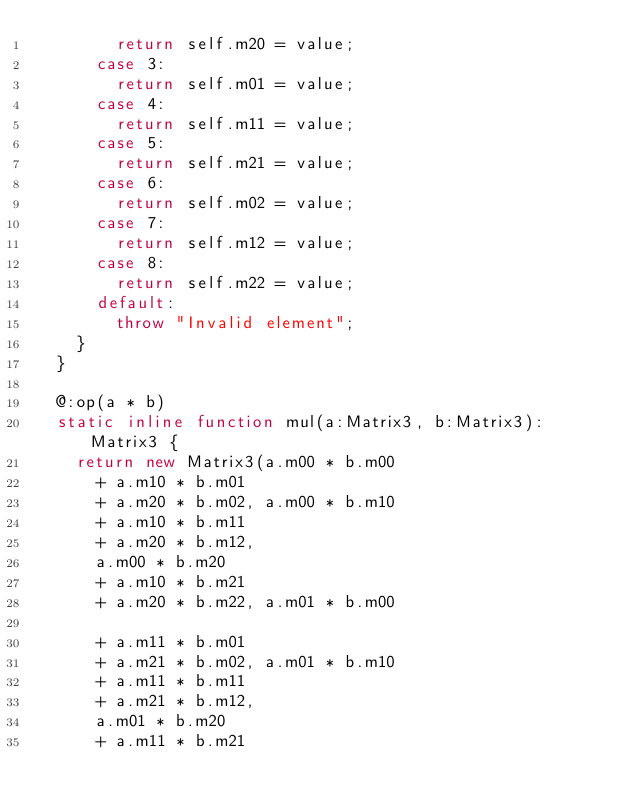Convert code to text. <code><loc_0><loc_0><loc_500><loc_500><_Haxe_>        return self.m20 = value;
      case 3:
        return self.m01 = value;
      case 4:
        return self.m11 = value;
      case 5:
        return self.m21 = value;
      case 6:
        return self.m02 = value;
      case 7:
        return self.m12 = value;
      case 8:
        return self.m22 = value;
      default:
        throw "Invalid element";
    }
  }

  @:op(a * b)
  static inline function mul(a:Matrix3, b:Matrix3):Matrix3 {
    return new Matrix3(a.m00 * b.m00
      + a.m10 * b.m01
      + a.m20 * b.m02, a.m00 * b.m10
      + a.m10 * b.m11
      + a.m20 * b.m12,
      a.m00 * b.m20
      + a.m10 * b.m21
      + a.m20 * b.m22, a.m01 * b.m00

      + a.m11 * b.m01
      + a.m21 * b.m02, a.m01 * b.m10
      + a.m11 * b.m11
      + a.m21 * b.m12,
      a.m01 * b.m20
      + a.m11 * b.m21</code> 